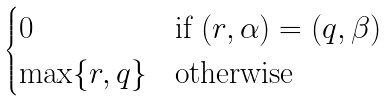<formula> <loc_0><loc_0><loc_500><loc_500>\begin{cases} 0 & \text {if } ( r , \alpha ) = ( q , \beta ) \\ \max \{ r , q \} & \text {otherwise} \end{cases}</formula> 